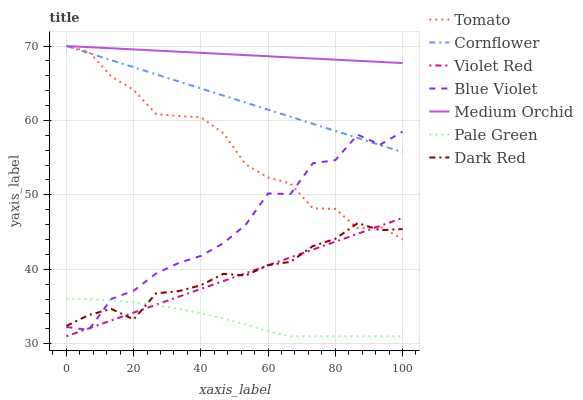Does Pale Green have the minimum area under the curve?
Answer yes or no. Yes. Does Medium Orchid have the maximum area under the curve?
Answer yes or no. Yes. Does Cornflower have the minimum area under the curve?
Answer yes or no. No. Does Cornflower have the maximum area under the curve?
Answer yes or no. No. Is Violet Red the smoothest?
Answer yes or no. Yes. Is Blue Violet the roughest?
Answer yes or no. Yes. Is Cornflower the smoothest?
Answer yes or no. No. Is Cornflower the roughest?
Answer yes or no. No. Does Violet Red have the lowest value?
Answer yes or no. Yes. Does Cornflower have the lowest value?
Answer yes or no. No. Does Medium Orchid have the highest value?
Answer yes or no. Yes. Does Violet Red have the highest value?
Answer yes or no. No. Is Pale Green less than Medium Orchid?
Answer yes or no. Yes. Is Medium Orchid greater than Pale Green?
Answer yes or no. Yes. Does Tomato intersect Medium Orchid?
Answer yes or no. Yes. Is Tomato less than Medium Orchid?
Answer yes or no. No. Is Tomato greater than Medium Orchid?
Answer yes or no. No. Does Pale Green intersect Medium Orchid?
Answer yes or no. No. 